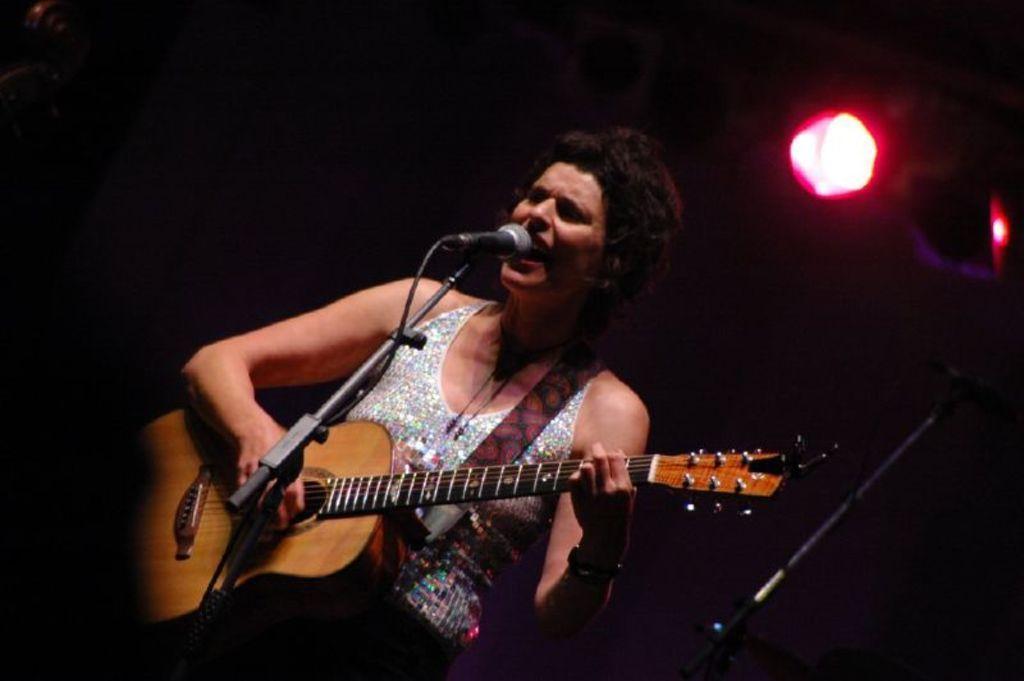Can you describe this image briefly? In this image In the middle there is a woman she is singing her hair is short she is playing guitar and there is a mic. In the background there is a light. 